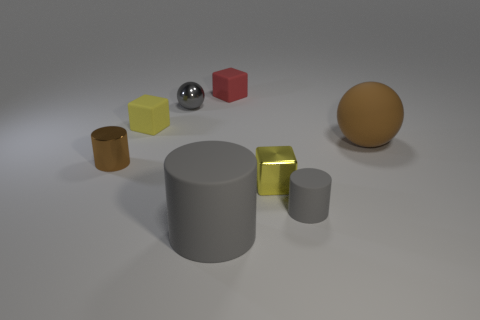Subtract all rubber cylinders. How many cylinders are left? 1 Subtract all brown balls. How many balls are left? 1 Add 1 big matte balls. How many objects exist? 9 Subtract all cylinders. How many objects are left? 5 Subtract 3 blocks. How many blocks are left? 0 Subtract all yellow cylinders. Subtract all red cubes. How many cylinders are left? 3 Subtract all cyan cylinders. How many yellow blocks are left? 2 Subtract all small rubber things. Subtract all big brown rubber things. How many objects are left? 4 Add 4 tiny yellow blocks. How many tiny yellow blocks are left? 6 Add 3 small gray metal objects. How many small gray metal objects exist? 4 